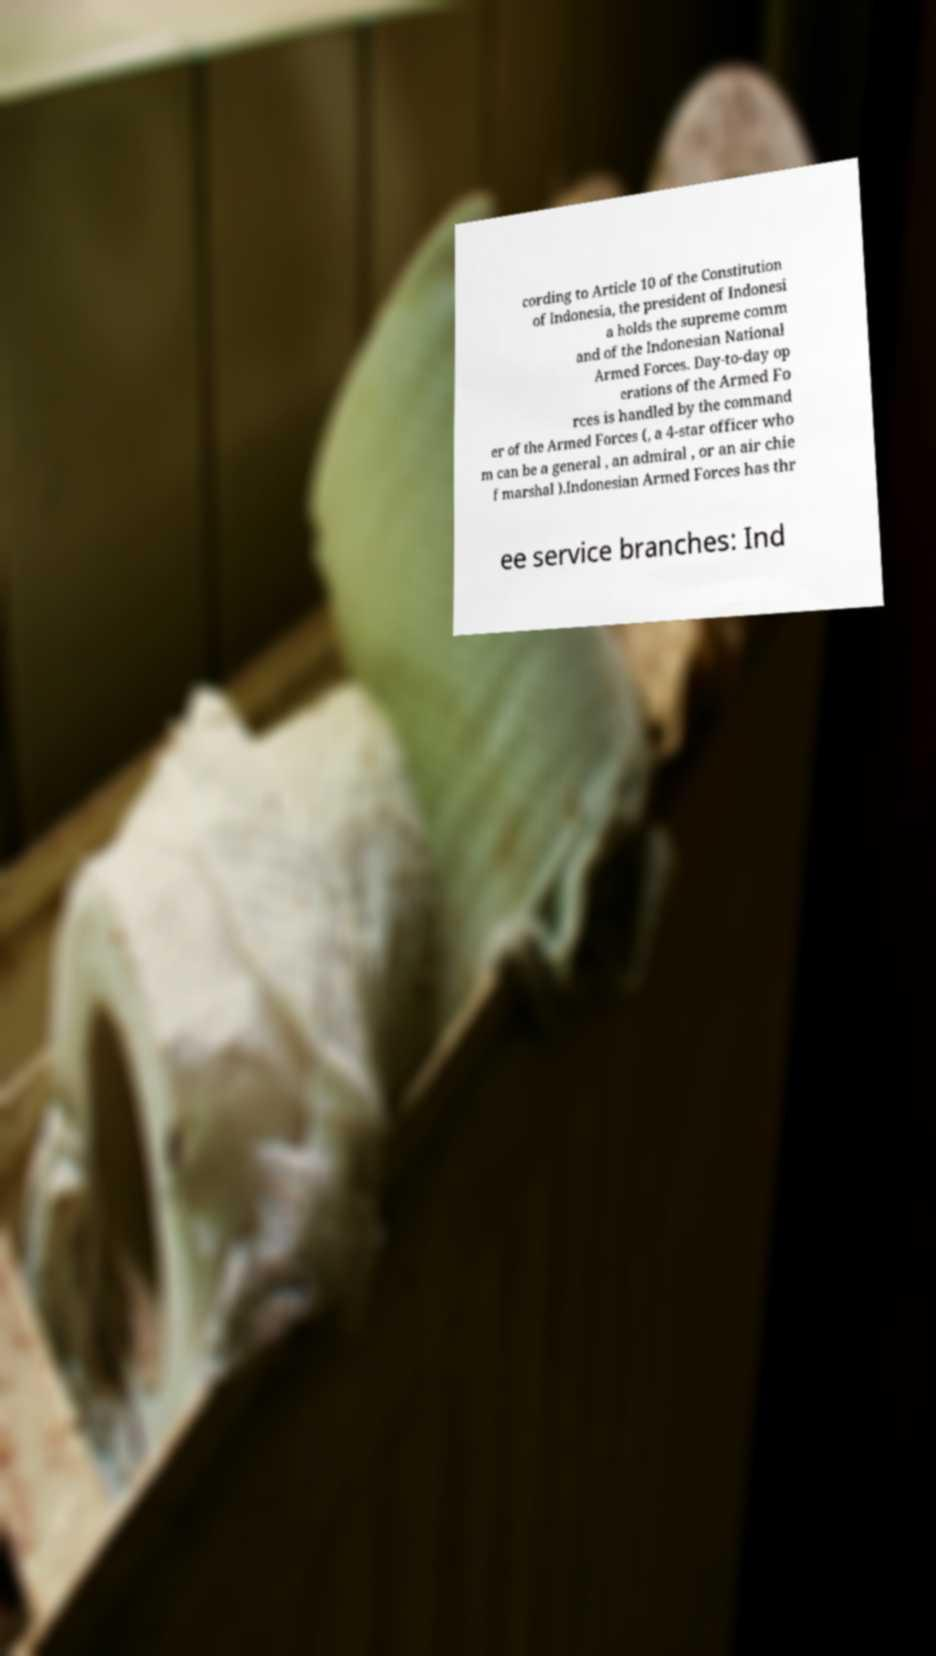I need the written content from this picture converted into text. Can you do that? cording to Article 10 of the Constitution of Indonesia, the president of Indonesi a holds the supreme comm and of the Indonesian National Armed Forces. Day-to-day op erations of the Armed Fo rces is handled by the command er of the Armed Forces (, a 4-star officer who m can be a general , an admiral , or an air chie f marshal ).Indonesian Armed Forces has thr ee service branches: Ind 